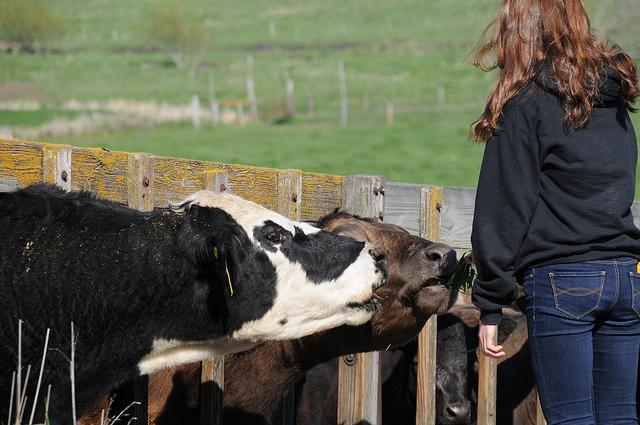Who is the woman feeding the cows? farmer 